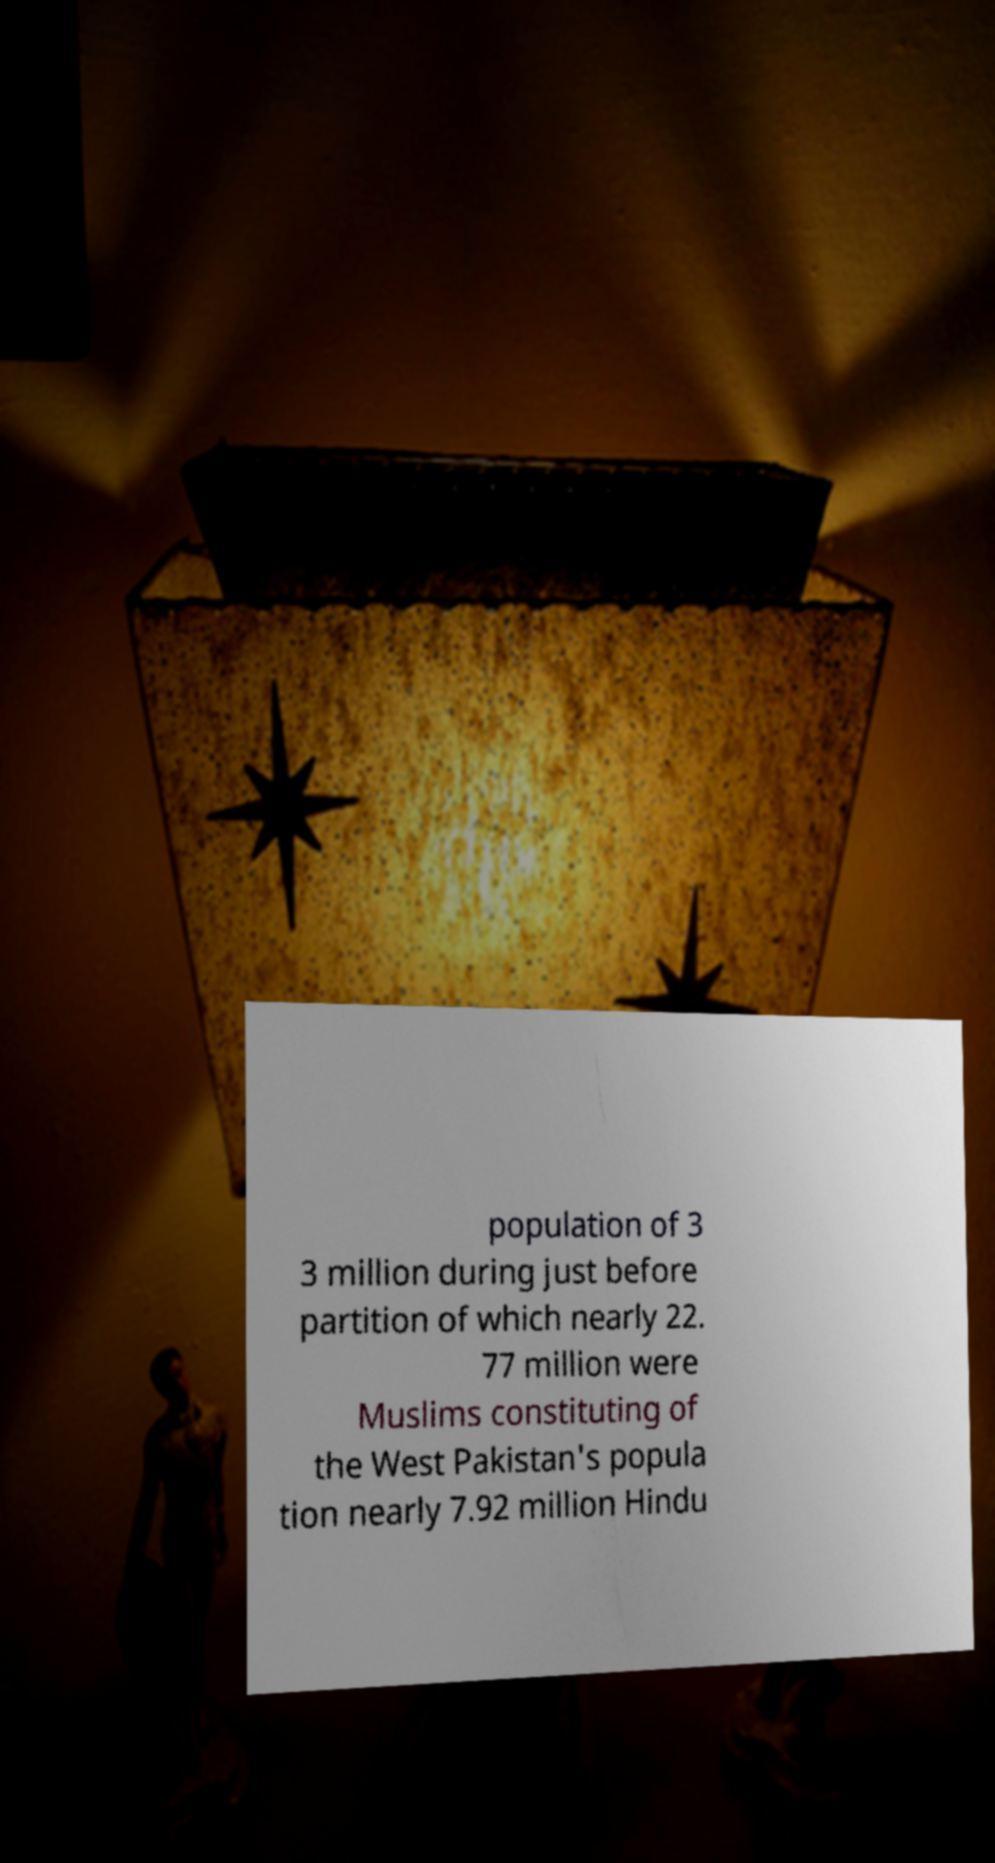Can you accurately transcribe the text from the provided image for me? population of 3 3 million during just before partition of which nearly 22. 77 million were Muslims constituting of the West Pakistan's popula tion nearly 7.92 million Hindu 